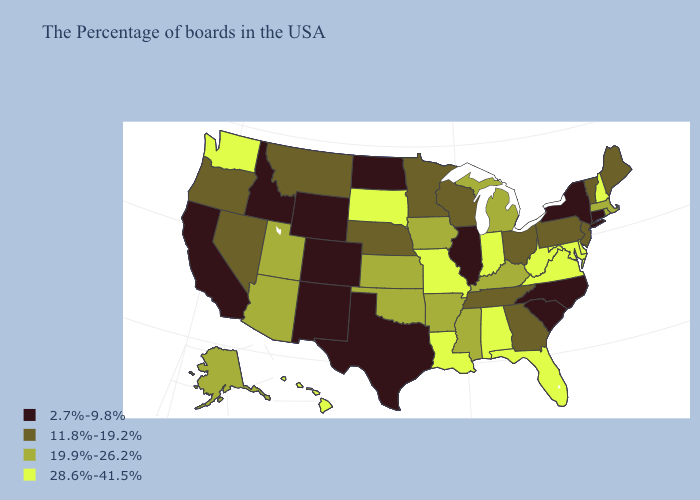Name the states that have a value in the range 2.7%-9.8%?
Answer briefly. Connecticut, New York, North Carolina, South Carolina, Illinois, Texas, North Dakota, Wyoming, Colorado, New Mexico, Idaho, California. What is the highest value in the South ?
Quick response, please. 28.6%-41.5%. Does Michigan have the highest value in the USA?
Concise answer only. No. What is the lowest value in the USA?
Give a very brief answer. 2.7%-9.8%. Which states have the lowest value in the USA?
Give a very brief answer. Connecticut, New York, North Carolina, South Carolina, Illinois, Texas, North Dakota, Wyoming, Colorado, New Mexico, Idaho, California. What is the value of Vermont?
Be succinct. 11.8%-19.2%. Which states have the highest value in the USA?
Answer briefly. New Hampshire, Delaware, Maryland, Virginia, West Virginia, Florida, Indiana, Alabama, Louisiana, Missouri, South Dakota, Washington, Hawaii. Which states hav the highest value in the West?
Give a very brief answer. Washington, Hawaii. What is the highest value in states that border South Carolina?
Be succinct. 11.8%-19.2%. Does New Mexico have a higher value than West Virginia?
Be succinct. No. What is the highest value in the USA?
Give a very brief answer. 28.6%-41.5%. Name the states that have a value in the range 28.6%-41.5%?
Quick response, please. New Hampshire, Delaware, Maryland, Virginia, West Virginia, Florida, Indiana, Alabama, Louisiana, Missouri, South Dakota, Washington, Hawaii. Which states have the lowest value in the USA?
Answer briefly. Connecticut, New York, North Carolina, South Carolina, Illinois, Texas, North Dakota, Wyoming, Colorado, New Mexico, Idaho, California. Does New Jersey have a higher value than California?
Quick response, please. Yes. What is the value of New Mexico?
Quick response, please. 2.7%-9.8%. 